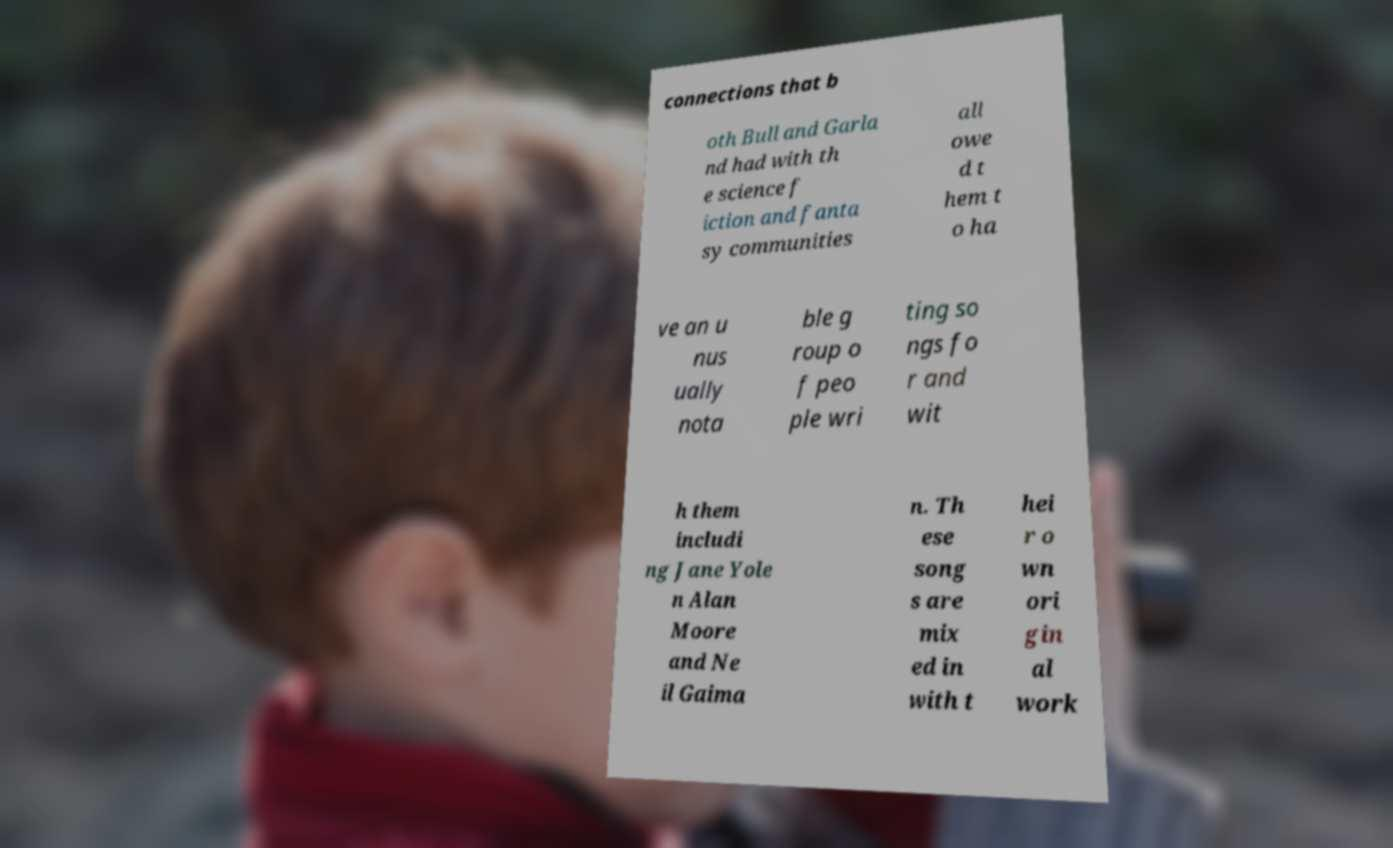There's text embedded in this image that I need extracted. Can you transcribe it verbatim? connections that b oth Bull and Garla nd had with th e science f iction and fanta sy communities all owe d t hem t o ha ve an u nus ually nota ble g roup o f peo ple wri ting so ngs fo r and wit h them includi ng Jane Yole n Alan Moore and Ne il Gaima n. Th ese song s are mix ed in with t hei r o wn ori gin al work 